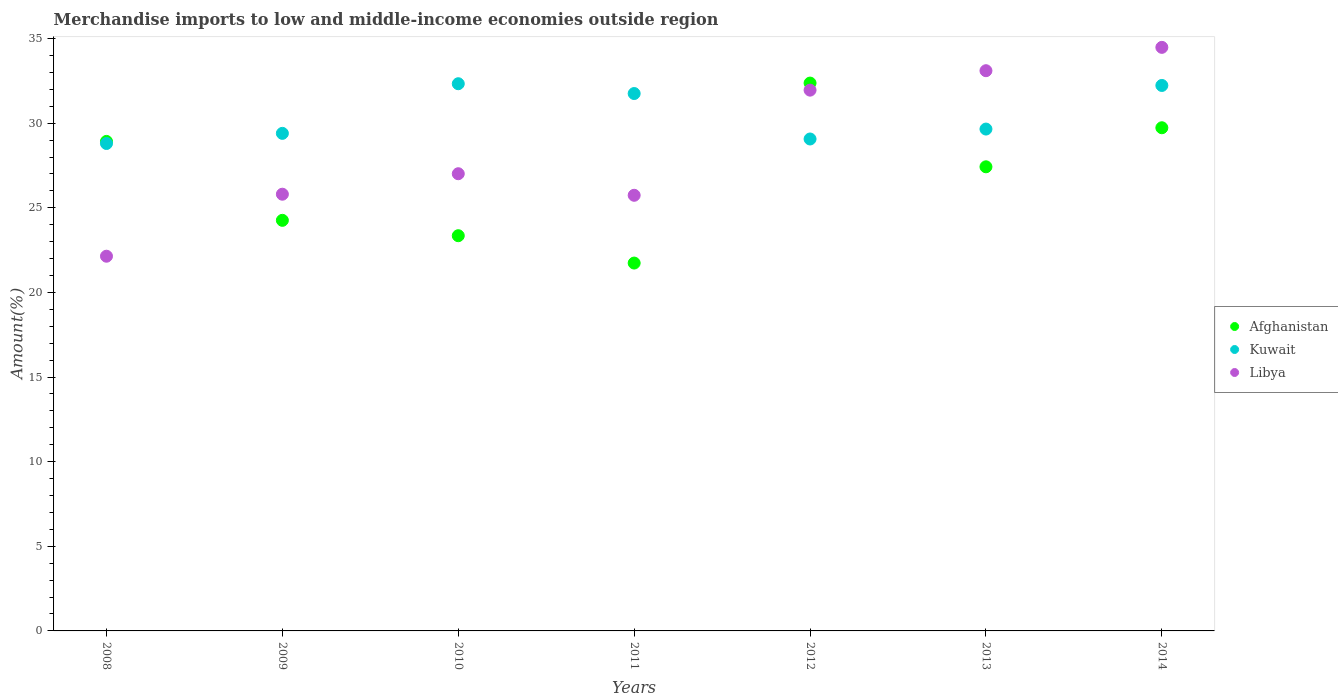What is the percentage of amount earned from merchandise imports in Kuwait in 2011?
Give a very brief answer. 31.75. Across all years, what is the maximum percentage of amount earned from merchandise imports in Afghanistan?
Provide a short and direct response. 32.37. Across all years, what is the minimum percentage of amount earned from merchandise imports in Kuwait?
Keep it short and to the point. 28.8. In which year was the percentage of amount earned from merchandise imports in Kuwait maximum?
Ensure brevity in your answer.  2010. In which year was the percentage of amount earned from merchandise imports in Libya minimum?
Offer a terse response. 2008. What is the total percentage of amount earned from merchandise imports in Afghanistan in the graph?
Keep it short and to the point. 187.8. What is the difference between the percentage of amount earned from merchandise imports in Kuwait in 2008 and that in 2011?
Give a very brief answer. -2.95. What is the difference between the percentage of amount earned from merchandise imports in Afghanistan in 2009 and the percentage of amount earned from merchandise imports in Kuwait in 2012?
Give a very brief answer. -4.81. What is the average percentage of amount earned from merchandise imports in Libya per year?
Provide a succinct answer. 28.61. In the year 2012, what is the difference between the percentage of amount earned from merchandise imports in Libya and percentage of amount earned from merchandise imports in Kuwait?
Provide a short and direct response. 2.89. In how many years, is the percentage of amount earned from merchandise imports in Libya greater than 25 %?
Make the answer very short. 6. What is the ratio of the percentage of amount earned from merchandise imports in Libya in 2008 to that in 2011?
Your response must be concise. 0.86. Is the percentage of amount earned from merchandise imports in Libya in 2013 less than that in 2014?
Provide a succinct answer. Yes. What is the difference between the highest and the second highest percentage of amount earned from merchandise imports in Afghanistan?
Offer a terse response. 2.64. What is the difference between the highest and the lowest percentage of amount earned from merchandise imports in Libya?
Make the answer very short. 12.34. Is the sum of the percentage of amount earned from merchandise imports in Libya in 2009 and 2014 greater than the maximum percentage of amount earned from merchandise imports in Kuwait across all years?
Offer a terse response. Yes. Is it the case that in every year, the sum of the percentage of amount earned from merchandise imports in Kuwait and percentage of amount earned from merchandise imports in Afghanistan  is greater than the percentage of amount earned from merchandise imports in Libya?
Your answer should be very brief. Yes. Is the percentage of amount earned from merchandise imports in Kuwait strictly less than the percentage of amount earned from merchandise imports in Afghanistan over the years?
Your response must be concise. No. How many years are there in the graph?
Offer a very short reply. 7. Does the graph contain any zero values?
Provide a short and direct response. No. Does the graph contain grids?
Provide a succinct answer. No. How many legend labels are there?
Provide a short and direct response. 3. How are the legend labels stacked?
Keep it short and to the point. Vertical. What is the title of the graph?
Provide a succinct answer. Merchandise imports to low and middle-income economies outside region. What is the label or title of the Y-axis?
Give a very brief answer. Amount(%). What is the Amount(%) of Afghanistan in 2008?
Offer a very short reply. 28.93. What is the Amount(%) of Kuwait in 2008?
Your answer should be compact. 28.8. What is the Amount(%) of Libya in 2008?
Offer a very short reply. 22.14. What is the Amount(%) in Afghanistan in 2009?
Give a very brief answer. 24.26. What is the Amount(%) of Kuwait in 2009?
Make the answer very short. 29.4. What is the Amount(%) of Libya in 2009?
Offer a terse response. 25.81. What is the Amount(%) in Afghanistan in 2010?
Keep it short and to the point. 23.35. What is the Amount(%) in Kuwait in 2010?
Give a very brief answer. 32.33. What is the Amount(%) of Libya in 2010?
Ensure brevity in your answer.  27.02. What is the Amount(%) in Afghanistan in 2011?
Your answer should be compact. 21.74. What is the Amount(%) of Kuwait in 2011?
Your answer should be very brief. 31.75. What is the Amount(%) of Libya in 2011?
Provide a succinct answer. 25.74. What is the Amount(%) in Afghanistan in 2012?
Provide a short and direct response. 32.37. What is the Amount(%) of Kuwait in 2012?
Your response must be concise. 29.07. What is the Amount(%) of Libya in 2012?
Your answer should be compact. 31.95. What is the Amount(%) in Afghanistan in 2013?
Provide a short and direct response. 27.42. What is the Amount(%) in Kuwait in 2013?
Offer a terse response. 29.65. What is the Amount(%) in Libya in 2013?
Offer a very short reply. 33.1. What is the Amount(%) in Afghanistan in 2014?
Provide a short and direct response. 29.73. What is the Amount(%) of Kuwait in 2014?
Offer a terse response. 32.23. What is the Amount(%) of Libya in 2014?
Your response must be concise. 34.48. Across all years, what is the maximum Amount(%) of Afghanistan?
Offer a terse response. 32.37. Across all years, what is the maximum Amount(%) in Kuwait?
Your response must be concise. 32.33. Across all years, what is the maximum Amount(%) in Libya?
Ensure brevity in your answer.  34.48. Across all years, what is the minimum Amount(%) of Afghanistan?
Make the answer very short. 21.74. Across all years, what is the minimum Amount(%) in Kuwait?
Offer a terse response. 28.8. Across all years, what is the minimum Amount(%) of Libya?
Make the answer very short. 22.14. What is the total Amount(%) in Afghanistan in the graph?
Your response must be concise. 187.8. What is the total Amount(%) of Kuwait in the graph?
Your response must be concise. 213.24. What is the total Amount(%) in Libya in the graph?
Make the answer very short. 200.24. What is the difference between the Amount(%) of Afghanistan in 2008 and that in 2009?
Offer a terse response. 4.66. What is the difference between the Amount(%) of Kuwait in 2008 and that in 2009?
Give a very brief answer. -0.6. What is the difference between the Amount(%) in Libya in 2008 and that in 2009?
Your answer should be very brief. -3.66. What is the difference between the Amount(%) of Afghanistan in 2008 and that in 2010?
Provide a succinct answer. 5.57. What is the difference between the Amount(%) of Kuwait in 2008 and that in 2010?
Your answer should be very brief. -3.53. What is the difference between the Amount(%) in Libya in 2008 and that in 2010?
Offer a terse response. -4.87. What is the difference between the Amount(%) in Afghanistan in 2008 and that in 2011?
Offer a terse response. 7.19. What is the difference between the Amount(%) of Kuwait in 2008 and that in 2011?
Ensure brevity in your answer.  -2.95. What is the difference between the Amount(%) in Libya in 2008 and that in 2011?
Your answer should be very brief. -3.6. What is the difference between the Amount(%) in Afghanistan in 2008 and that in 2012?
Your answer should be very brief. -3.45. What is the difference between the Amount(%) of Kuwait in 2008 and that in 2012?
Offer a very short reply. -0.27. What is the difference between the Amount(%) in Libya in 2008 and that in 2012?
Your response must be concise. -9.81. What is the difference between the Amount(%) of Afghanistan in 2008 and that in 2013?
Your response must be concise. 1.5. What is the difference between the Amount(%) of Kuwait in 2008 and that in 2013?
Ensure brevity in your answer.  -0.85. What is the difference between the Amount(%) in Libya in 2008 and that in 2013?
Keep it short and to the point. -10.96. What is the difference between the Amount(%) in Afghanistan in 2008 and that in 2014?
Your response must be concise. -0.81. What is the difference between the Amount(%) in Kuwait in 2008 and that in 2014?
Make the answer very short. -3.43. What is the difference between the Amount(%) in Libya in 2008 and that in 2014?
Offer a terse response. -12.34. What is the difference between the Amount(%) in Afghanistan in 2009 and that in 2010?
Keep it short and to the point. 0.91. What is the difference between the Amount(%) of Kuwait in 2009 and that in 2010?
Provide a succinct answer. -2.93. What is the difference between the Amount(%) in Libya in 2009 and that in 2010?
Your response must be concise. -1.21. What is the difference between the Amount(%) in Afghanistan in 2009 and that in 2011?
Keep it short and to the point. 2.52. What is the difference between the Amount(%) of Kuwait in 2009 and that in 2011?
Offer a very short reply. -2.35. What is the difference between the Amount(%) of Libya in 2009 and that in 2011?
Your answer should be very brief. 0.06. What is the difference between the Amount(%) in Afghanistan in 2009 and that in 2012?
Provide a succinct answer. -8.11. What is the difference between the Amount(%) in Kuwait in 2009 and that in 2012?
Give a very brief answer. 0.33. What is the difference between the Amount(%) in Libya in 2009 and that in 2012?
Provide a succinct answer. -6.15. What is the difference between the Amount(%) in Afghanistan in 2009 and that in 2013?
Give a very brief answer. -3.16. What is the difference between the Amount(%) of Kuwait in 2009 and that in 2013?
Make the answer very short. -0.25. What is the difference between the Amount(%) in Libya in 2009 and that in 2013?
Provide a succinct answer. -7.3. What is the difference between the Amount(%) in Afghanistan in 2009 and that in 2014?
Ensure brevity in your answer.  -5.47. What is the difference between the Amount(%) in Kuwait in 2009 and that in 2014?
Offer a terse response. -2.83. What is the difference between the Amount(%) of Libya in 2009 and that in 2014?
Keep it short and to the point. -8.68. What is the difference between the Amount(%) of Afghanistan in 2010 and that in 2011?
Your answer should be compact. 1.62. What is the difference between the Amount(%) of Kuwait in 2010 and that in 2011?
Your answer should be compact. 0.58. What is the difference between the Amount(%) of Libya in 2010 and that in 2011?
Your response must be concise. 1.27. What is the difference between the Amount(%) of Afghanistan in 2010 and that in 2012?
Offer a terse response. -9.02. What is the difference between the Amount(%) of Kuwait in 2010 and that in 2012?
Your response must be concise. 3.27. What is the difference between the Amount(%) of Libya in 2010 and that in 2012?
Give a very brief answer. -4.94. What is the difference between the Amount(%) in Afghanistan in 2010 and that in 2013?
Provide a short and direct response. -4.07. What is the difference between the Amount(%) in Kuwait in 2010 and that in 2013?
Provide a short and direct response. 2.68. What is the difference between the Amount(%) of Libya in 2010 and that in 2013?
Provide a succinct answer. -6.09. What is the difference between the Amount(%) in Afghanistan in 2010 and that in 2014?
Your answer should be very brief. -6.38. What is the difference between the Amount(%) in Kuwait in 2010 and that in 2014?
Your response must be concise. 0.1. What is the difference between the Amount(%) of Libya in 2010 and that in 2014?
Your response must be concise. -7.47. What is the difference between the Amount(%) in Afghanistan in 2011 and that in 2012?
Give a very brief answer. -10.63. What is the difference between the Amount(%) of Kuwait in 2011 and that in 2012?
Your response must be concise. 2.69. What is the difference between the Amount(%) in Libya in 2011 and that in 2012?
Provide a succinct answer. -6.21. What is the difference between the Amount(%) of Afghanistan in 2011 and that in 2013?
Your answer should be compact. -5.69. What is the difference between the Amount(%) of Kuwait in 2011 and that in 2013?
Your answer should be compact. 2.1. What is the difference between the Amount(%) of Libya in 2011 and that in 2013?
Your answer should be very brief. -7.36. What is the difference between the Amount(%) of Afghanistan in 2011 and that in 2014?
Keep it short and to the point. -8. What is the difference between the Amount(%) of Kuwait in 2011 and that in 2014?
Provide a succinct answer. -0.48. What is the difference between the Amount(%) of Libya in 2011 and that in 2014?
Your response must be concise. -8.74. What is the difference between the Amount(%) in Afghanistan in 2012 and that in 2013?
Provide a succinct answer. 4.95. What is the difference between the Amount(%) in Kuwait in 2012 and that in 2013?
Offer a very short reply. -0.59. What is the difference between the Amount(%) of Libya in 2012 and that in 2013?
Your response must be concise. -1.15. What is the difference between the Amount(%) in Afghanistan in 2012 and that in 2014?
Keep it short and to the point. 2.64. What is the difference between the Amount(%) in Kuwait in 2012 and that in 2014?
Ensure brevity in your answer.  -3.16. What is the difference between the Amount(%) in Libya in 2012 and that in 2014?
Your response must be concise. -2.53. What is the difference between the Amount(%) of Afghanistan in 2013 and that in 2014?
Offer a terse response. -2.31. What is the difference between the Amount(%) in Kuwait in 2013 and that in 2014?
Your response must be concise. -2.58. What is the difference between the Amount(%) of Libya in 2013 and that in 2014?
Give a very brief answer. -1.38. What is the difference between the Amount(%) of Afghanistan in 2008 and the Amount(%) of Kuwait in 2009?
Offer a very short reply. -0.48. What is the difference between the Amount(%) in Afghanistan in 2008 and the Amount(%) in Libya in 2009?
Provide a succinct answer. 3.12. What is the difference between the Amount(%) in Kuwait in 2008 and the Amount(%) in Libya in 2009?
Your response must be concise. 3. What is the difference between the Amount(%) in Afghanistan in 2008 and the Amount(%) in Kuwait in 2010?
Provide a short and direct response. -3.41. What is the difference between the Amount(%) in Afghanistan in 2008 and the Amount(%) in Libya in 2010?
Your answer should be compact. 1.91. What is the difference between the Amount(%) in Kuwait in 2008 and the Amount(%) in Libya in 2010?
Give a very brief answer. 1.79. What is the difference between the Amount(%) of Afghanistan in 2008 and the Amount(%) of Kuwait in 2011?
Provide a succinct answer. -2.83. What is the difference between the Amount(%) of Afghanistan in 2008 and the Amount(%) of Libya in 2011?
Provide a short and direct response. 3.18. What is the difference between the Amount(%) of Kuwait in 2008 and the Amount(%) of Libya in 2011?
Give a very brief answer. 3.06. What is the difference between the Amount(%) of Afghanistan in 2008 and the Amount(%) of Kuwait in 2012?
Provide a short and direct response. -0.14. What is the difference between the Amount(%) in Afghanistan in 2008 and the Amount(%) in Libya in 2012?
Provide a succinct answer. -3.03. What is the difference between the Amount(%) in Kuwait in 2008 and the Amount(%) in Libya in 2012?
Ensure brevity in your answer.  -3.15. What is the difference between the Amount(%) of Afghanistan in 2008 and the Amount(%) of Kuwait in 2013?
Offer a terse response. -0.73. What is the difference between the Amount(%) in Afghanistan in 2008 and the Amount(%) in Libya in 2013?
Give a very brief answer. -4.18. What is the difference between the Amount(%) of Kuwait in 2008 and the Amount(%) of Libya in 2013?
Offer a terse response. -4.3. What is the difference between the Amount(%) in Afghanistan in 2008 and the Amount(%) in Kuwait in 2014?
Give a very brief answer. -3.31. What is the difference between the Amount(%) of Afghanistan in 2008 and the Amount(%) of Libya in 2014?
Give a very brief answer. -5.56. What is the difference between the Amount(%) in Kuwait in 2008 and the Amount(%) in Libya in 2014?
Ensure brevity in your answer.  -5.68. What is the difference between the Amount(%) of Afghanistan in 2009 and the Amount(%) of Kuwait in 2010?
Make the answer very short. -8.07. What is the difference between the Amount(%) of Afghanistan in 2009 and the Amount(%) of Libya in 2010?
Keep it short and to the point. -2.75. What is the difference between the Amount(%) in Kuwait in 2009 and the Amount(%) in Libya in 2010?
Give a very brief answer. 2.39. What is the difference between the Amount(%) in Afghanistan in 2009 and the Amount(%) in Kuwait in 2011?
Offer a terse response. -7.49. What is the difference between the Amount(%) of Afghanistan in 2009 and the Amount(%) of Libya in 2011?
Ensure brevity in your answer.  -1.48. What is the difference between the Amount(%) of Kuwait in 2009 and the Amount(%) of Libya in 2011?
Give a very brief answer. 3.66. What is the difference between the Amount(%) in Afghanistan in 2009 and the Amount(%) in Kuwait in 2012?
Ensure brevity in your answer.  -4.81. What is the difference between the Amount(%) in Afghanistan in 2009 and the Amount(%) in Libya in 2012?
Provide a short and direct response. -7.69. What is the difference between the Amount(%) of Kuwait in 2009 and the Amount(%) of Libya in 2012?
Make the answer very short. -2.55. What is the difference between the Amount(%) of Afghanistan in 2009 and the Amount(%) of Kuwait in 2013?
Your answer should be very brief. -5.39. What is the difference between the Amount(%) of Afghanistan in 2009 and the Amount(%) of Libya in 2013?
Provide a short and direct response. -8.84. What is the difference between the Amount(%) in Kuwait in 2009 and the Amount(%) in Libya in 2013?
Your answer should be compact. -3.7. What is the difference between the Amount(%) of Afghanistan in 2009 and the Amount(%) of Kuwait in 2014?
Your answer should be compact. -7.97. What is the difference between the Amount(%) in Afghanistan in 2009 and the Amount(%) in Libya in 2014?
Ensure brevity in your answer.  -10.22. What is the difference between the Amount(%) of Kuwait in 2009 and the Amount(%) of Libya in 2014?
Make the answer very short. -5.08. What is the difference between the Amount(%) of Afghanistan in 2010 and the Amount(%) of Kuwait in 2011?
Your answer should be compact. -8.4. What is the difference between the Amount(%) of Afghanistan in 2010 and the Amount(%) of Libya in 2011?
Make the answer very short. -2.39. What is the difference between the Amount(%) of Kuwait in 2010 and the Amount(%) of Libya in 2011?
Give a very brief answer. 6.59. What is the difference between the Amount(%) of Afghanistan in 2010 and the Amount(%) of Kuwait in 2012?
Your answer should be compact. -5.71. What is the difference between the Amount(%) in Afghanistan in 2010 and the Amount(%) in Libya in 2012?
Your answer should be compact. -8.6. What is the difference between the Amount(%) in Kuwait in 2010 and the Amount(%) in Libya in 2012?
Your answer should be very brief. 0.38. What is the difference between the Amount(%) in Afghanistan in 2010 and the Amount(%) in Kuwait in 2013?
Your answer should be compact. -6.3. What is the difference between the Amount(%) of Afghanistan in 2010 and the Amount(%) of Libya in 2013?
Provide a short and direct response. -9.75. What is the difference between the Amount(%) in Kuwait in 2010 and the Amount(%) in Libya in 2013?
Your answer should be compact. -0.77. What is the difference between the Amount(%) in Afghanistan in 2010 and the Amount(%) in Kuwait in 2014?
Provide a short and direct response. -8.88. What is the difference between the Amount(%) in Afghanistan in 2010 and the Amount(%) in Libya in 2014?
Provide a short and direct response. -11.13. What is the difference between the Amount(%) in Kuwait in 2010 and the Amount(%) in Libya in 2014?
Provide a succinct answer. -2.15. What is the difference between the Amount(%) of Afghanistan in 2011 and the Amount(%) of Kuwait in 2012?
Offer a very short reply. -7.33. What is the difference between the Amount(%) of Afghanistan in 2011 and the Amount(%) of Libya in 2012?
Ensure brevity in your answer.  -10.22. What is the difference between the Amount(%) of Kuwait in 2011 and the Amount(%) of Libya in 2012?
Keep it short and to the point. -0.2. What is the difference between the Amount(%) of Afghanistan in 2011 and the Amount(%) of Kuwait in 2013?
Ensure brevity in your answer.  -7.92. What is the difference between the Amount(%) of Afghanistan in 2011 and the Amount(%) of Libya in 2013?
Offer a terse response. -11.37. What is the difference between the Amount(%) of Kuwait in 2011 and the Amount(%) of Libya in 2013?
Your response must be concise. -1.35. What is the difference between the Amount(%) of Afghanistan in 2011 and the Amount(%) of Kuwait in 2014?
Give a very brief answer. -10.49. What is the difference between the Amount(%) in Afghanistan in 2011 and the Amount(%) in Libya in 2014?
Your answer should be very brief. -12.75. What is the difference between the Amount(%) of Kuwait in 2011 and the Amount(%) of Libya in 2014?
Your answer should be very brief. -2.73. What is the difference between the Amount(%) of Afghanistan in 2012 and the Amount(%) of Kuwait in 2013?
Your response must be concise. 2.72. What is the difference between the Amount(%) in Afghanistan in 2012 and the Amount(%) in Libya in 2013?
Your answer should be very brief. -0.73. What is the difference between the Amount(%) of Kuwait in 2012 and the Amount(%) of Libya in 2013?
Your response must be concise. -4.04. What is the difference between the Amount(%) in Afghanistan in 2012 and the Amount(%) in Kuwait in 2014?
Keep it short and to the point. 0.14. What is the difference between the Amount(%) of Afghanistan in 2012 and the Amount(%) of Libya in 2014?
Provide a succinct answer. -2.11. What is the difference between the Amount(%) of Kuwait in 2012 and the Amount(%) of Libya in 2014?
Give a very brief answer. -5.41. What is the difference between the Amount(%) of Afghanistan in 2013 and the Amount(%) of Kuwait in 2014?
Give a very brief answer. -4.81. What is the difference between the Amount(%) in Afghanistan in 2013 and the Amount(%) in Libya in 2014?
Make the answer very short. -7.06. What is the difference between the Amount(%) of Kuwait in 2013 and the Amount(%) of Libya in 2014?
Ensure brevity in your answer.  -4.83. What is the average Amount(%) of Afghanistan per year?
Provide a short and direct response. 26.83. What is the average Amount(%) in Kuwait per year?
Ensure brevity in your answer.  30.46. What is the average Amount(%) in Libya per year?
Provide a short and direct response. 28.61. In the year 2008, what is the difference between the Amount(%) of Afghanistan and Amount(%) of Kuwait?
Provide a succinct answer. 0.12. In the year 2008, what is the difference between the Amount(%) in Afghanistan and Amount(%) in Libya?
Your answer should be very brief. 6.78. In the year 2008, what is the difference between the Amount(%) in Kuwait and Amount(%) in Libya?
Give a very brief answer. 6.66. In the year 2009, what is the difference between the Amount(%) of Afghanistan and Amount(%) of Kuwait?
Keep it short and to the point. -5.14. In the year 2009, what is the difference between the Amount(%) of Afghanistan and Amount(%) of Libya?
Offer a very short reply. -1.54. In the year 2009, what is the difference between the Amount(%) in Kuwait and Amount(%) in Libya?
Your answer should be compact. 3.6. In the year 2010, what is the difference between the Amount(%) of Afghanistan and Amount(%) of Kuwait?
Give a very brief answer. -8.98. In the year 2010, what is the difference between the Amount(%) of Afghanistan and Amount(%) of Libya?
Keep it short and to the point. -3.66. In the year 2010, what is the difference between the Amount(%) in Kuwait and Amount(%) in Libya?
Give a very brief answer. 5.32. In the year 2011, what is the difference between the Amount(%) in Afghanistan and Amount(%) in Kuwait?
Offer a terse response. -10.02. In the year 2011, what is the difference between the Amount(%) in Afghanistan and Amount(%) in Libya?
Your answer should be very brief. -4. In the year 2011, what is the difference between the Amount(%) of Kuwait and Amount(%) of Libya?
Your answer should be compact. 6.01. In the year 2012, what is the difference between the Amount(%) of Afghanistan and Amount(%) of Kuwait?
Provide a short and direct response. 3.3. In the year 2012, what is the difference between the Amount(%) in Afghanistan and Amount(%) in Libya?
Provide a succinct answer. 0.42. In the year 2012, what is the difference between the Amount(%) of Kuwait and Amount(%) of Libya?
Make the answer very short. -2.89. In the year 2013, what is the difference between the Amount(%) in Afghanistan and Amount(%) in Kuwait?
Your answer should be compact. -2.23. In the year 2013, what is the difference between the Amount(%) of Afghanistan and Amount(%) of Libya?
Provide a succinct answer. -5.68. In the year 2013, what is the difference between the Amount(%) in Kuwait and Amount(%) in Libya?
Your answer should be very brief. -3.45. In the year 2014, what is the difference between the Amount(%) of Afghanistan and Amount(%) of Kuwait?
Make the answer very short. -2.5. In the year 2014, what is the difference between the Amount(%) of Afghanistan and Amount(%) of Libya?
Give a very brief answer. -4.75. In the year 2014, what is the difference between the Amount(%) in Kuwait and Amount(%) in Libya?
Your answer should be compact. -2.25. What is the ratio of the Amount(%) of Afghanistan in 2008 to that in 2009?
Your response must be concise. 1.19. What is the ratio of the Amount(%) of Kuwait in 2008 to that in 2009?
Keep it short and to the point. 0.98. What is the ratio of the Amount(%) in Libya in 2008 to that in 2009?
Provide a short and direct response. 0.86. What is the ratio of the Amount(%) of Afghanistan in 2008 to that in 2010?
Offer a very short reply. 1.24. What is the ratio of the Amount(%) of Kuwait in 2008 to that in 2010?
Your answer should be very brief. 0.89. What is the ratio of the Amount(%) in Libya in 2008 to that in 2010?
Keep it short and to the point. 0.82. What is the ratio of the Amount(%) of Afghanistan in 2008 to that in 2011?
Your response must be concise. 1.33. What is the ratio of the Amount(%) in Kuwait in 2008 to that in 2011?
Ensure brevity in your answer.  0.91. What is the ratio of the Amount(%) of Libya in 2008 to that in 2011?
Your response must be concise. 0.86. What is the ratio of the Amount(%) of Afghanistan in 2008 to that in 2012?
Keep it short and to the point. 0.89. What is the ratio of the Amount(%) in Libya in 2008 to that in 2012?
Your response must be concise. 0.69. What is the ratio of the Amount(%) of Afghanistan in 2008 to that in 2013?
Provide a short and direct response. 1.05. What is the ratio of the Amount(%) of Kuwait in 2008 to that in 2013?
Offer a very short reply. 0.97. What is the ratio of the Amount(%) of Libya in 2008 to that in 2013?
Your answer should be very brief. 0.67. What is the ratio of the Amount(%) in Afghanistan in 2008 to that in 2014?
Ensure brevity in your answer.  0.97. What is the ratio of the Amount(%) in Kuwait in 2008 to that in 2014?
Your answer should be compact. 0.89. What is the ratio of the Amount(%) in Libya in 2008 to that in 2014?
Your answer should be compact. 0.64. What is the ratio of the Amount(%) of Afghanistan in 2009 to that in 2010?
Give a very brief answer. 1.04. What is the ratio of the Amount(%) of Kuwait in 2009 to that in 2010?
Offer a very short reply. 0.91. What is the ratio of the Amount(%) in Libya in 2009 to that in 2010?
Offer a very short reply. 0.96. What is the ratio of the Amount(%) of Afghanistan in 2009 to that in 2011?
Your answer should be very brief. 1.12. What is the ratio of the Amount(%) of Kuwait in 2009 to that in 2011?
Ensure brevity in your answer.  0.93. What is the ratio of the Amount(%) of Afghanistan in 2009 to that in 2012?
Provide a short and direct response. 0.75. What is the ratio of the Amount(%) in Kuwait in 2009 to that in 2012?
Keep it short and to the point. 1.01. What is the ratio of the Amount(%) of Libya in 2009 to that in 2012?
Provide a succinct answer. 0.81. What is the ratio of the Amount(%) of Afghanistan in 2009 to that in 2013?
Your response must be concise. 0.88. What is the ratio of the Amount(%) in Libya in 2009 to that in 2013?
Offer a terse response. 0.78. What is the ratio of the Amount(%) in Afghanistan in 2009 to that in 2014?
Make the answer very short. 0.82. What is the ratio of the Amount(%) of Kuwait in 2009 to that in 2014?
Offer a terse response. 0.91. What is the ratio of the Amount(%) of Libya in 2009 to that in 2014?
Offer a terse response. 0.75. What is the ratio of the Amount(%) of Afghanistan in 2010 to that in 2011?
Ensure brevity in your answer.  1.07. What is the ratio of the Amount(%) of Kuwait in 2010 to that in 2011?
Your answer should be compact. 1.02. What is the ratio of the Amount(%) in Libya in 2010 to that in 2011?
Give a very brief answer. 1.05. What is the ratio of the Amount(%) of Afghanistan in 2010 to that in 2012?
Keep it short and to the point. 0.72. What is the ratio of the Amount(%) in Kuwait in 2010 to that in 2012?
Provide a succinct answer. 1.11. What is the ratio of the Amount(%) in Libya in 2010 to that in 2012?
Your response must be concise. 0.85. What is the ratio of the Amount(%) in Afghanistan in 2010 to that in 2013?
Provide a short and direct response. 0.85. What is the ratio of the Amount(%) of Kuwait in 2010 to that in 2013?
Offer a very short reply. 1.09. What is the ratio of the Amount(%) of Libya in 2010 to that in 2013?
Offer a very short reply. 0.82. What is the ratio of the Amount(%) of Afghanistan in 2010 to that in 2014?
Your answer should be compact. 0.79. What is the ratio of the Amount(%) in Kuwait in 2010 to that in 2014?
Provide a succinct answer. 1. What is the ratio of the Amount(%) in Libya in 2010 to that in 2014?
Provide a succinct answer. 0.78. What is the ratio of the Amount(%) in Afghanistan in 2011 to that in 2012?
Offer a very short reply. 0.67. What is the ratio of the Amount(%) in Kuwait in 2011 to that in 2012?
Your answer should be very brief. 1.09. What is the ratio of the Amount(%) in Libya in 2011 to that in 2012?
Offer a very short reply. 0.81. What is the ratio of the Amount(%) of Afghanistan in 2011 to that in 2013?
Provide a succinct answer. 0.79. What is the ratio of the Amount(%) of Kuwait in 2011 to that in 2013?
Provide a succinct answer. 1.07. What is the ratio of the Amount(%) of Libya in 2011 to that in 2013?
Keep it short and to the point. 0.78. What is the ratio of the Amount(%) of Afghanistan in 2011 to that in 2014?
Your response must be concise. 0.73. What is the ratio of the Amount(%) of Kuwait in 2011 to that in 2014?
Your response must be concise. 0.99. What is the ratio of the Amount(%) of Libya in 2011 to that in 2014?
Your answer should be compact. 0.75. What is the ratio of the Amount(%) in Afghanistan in 2012 to that in 2013?
Your response must be concise. 1.18. What is the ratio of the Amount(%) in Kuwait in 2012 to that in 2013?
Provide a short and direct response. 0.98. What is the ratio of the Amount(%) in Libya in 2012 to that in 2013?
Your response must be concise. 0.97. What is the ratio of the Amount(%) of Afghanistan in 2012 to that in 2014?
Give a very brief answer. 1.09. What is the ratio of the Amount(%) of Kuwait in 2012 to that in 2014?
Keep it short and to the point. 0.9. What is the ratio of the Amount(%) of Libya in 2012 to that in 2014?
Offer a very short reply. 0.93. What is the ratio of the Amount(%) of Afghanistan in 2013 to that in 2014?
Provide a short and direct response. 0.92. What is the ratio of the Amount(%) of Kuwait in 2013 to that in 2014?
Ensure brevity in your answer.  0.92. What is the ratio of the Amount(%) in Libya in 2013 to that in 2014?
Offer a terse response. 0.96. What is the difference between the highest and the second highest Amount(%) of Afghanistan?
Offer a terse response. 2.64. What is the difference between the highest and the second highest Amount(%) of Kuwait?
Ensure brevity in your answer.  0.1. What is the difference between the highest and the second highest Amount(%) in Libya?
Ensure brevity in your answer.  1.38. What is the difference between the highest and the lowest Amount(%) in Afghanistan?
Your answer should be compact. 10.63. What is the difference between the highest and the lowest Amount(%) of Kuwait?
Your answer should be very brief. 3.53. What is the difference between the highest and the lowest Amount(%) of Libya?
Offer a terse response. 12.34. 